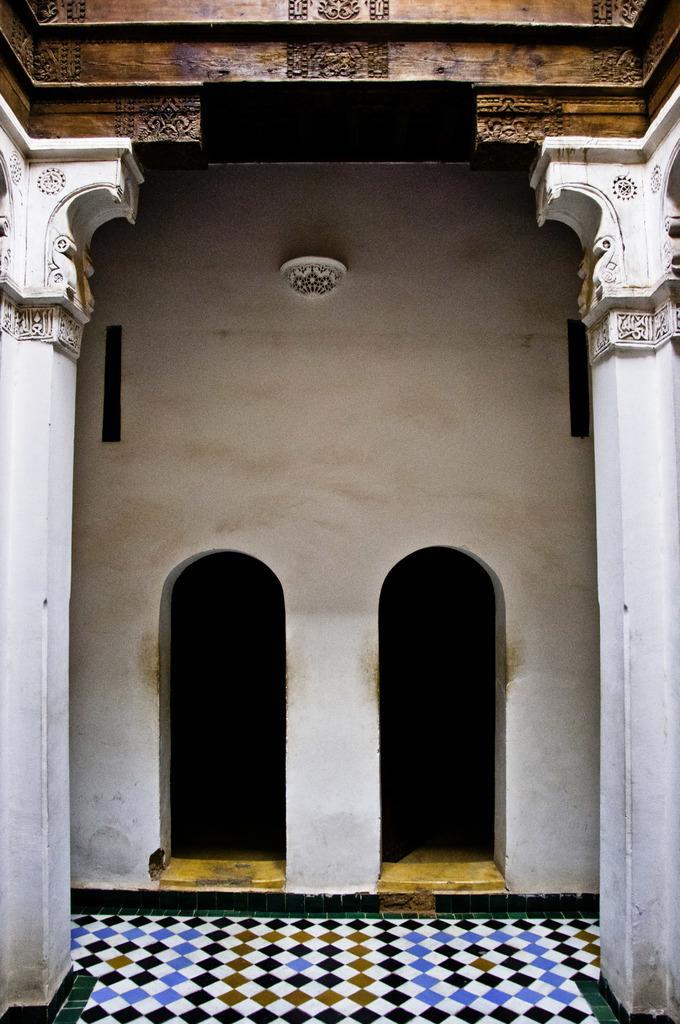In one or two sentences, can you explain what this image depicts? In this image, we can see a building and at the bottom, there is a floor. 